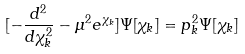<formula> <loc_0><loc_0><loc_500><loc_500>[ - \frac { d ^ { 2 } } { d \chi _ { k } ^ { 2 } } - \mu ^ { 2 } e ^ { \chi _ { k } } ] \Psi [ \chi _ { k } ] = p _ { k } ^ { 2 } \Psi [ \chi _ { k } ]</formula> 